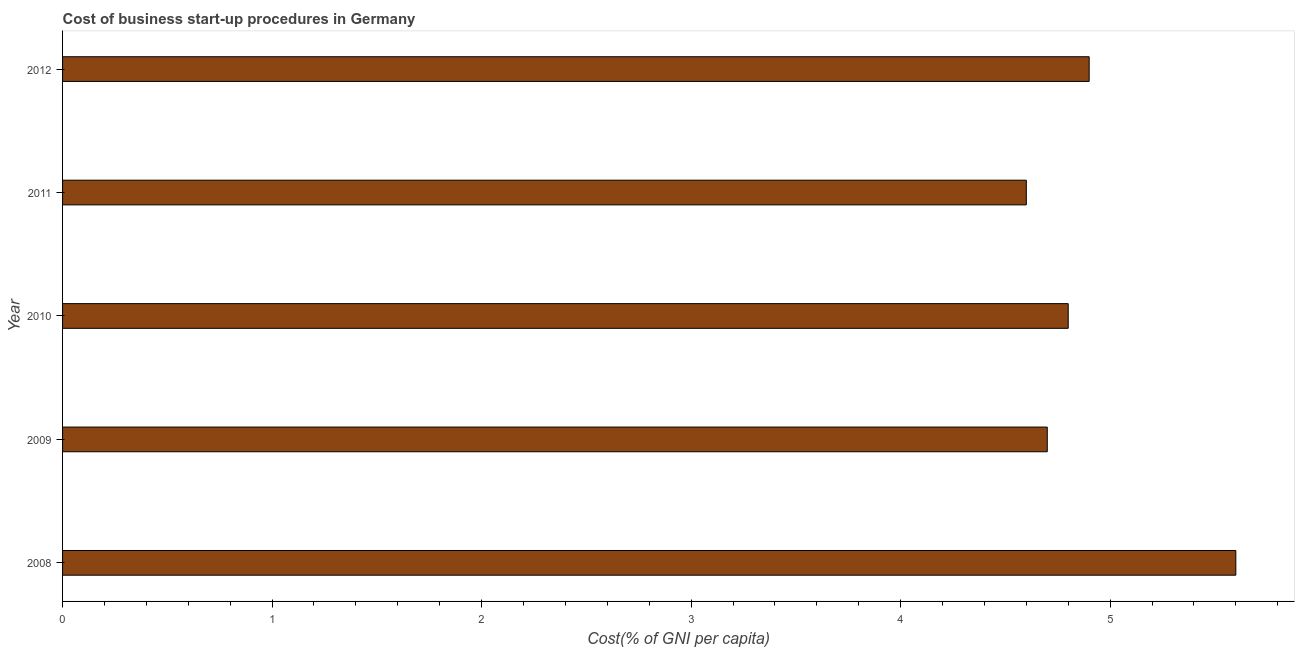Does the graph contain grids?
Provide a succinct answer. No. What is the title of the graph?
Ensure brevity in your answer.  Cost of business start-up procedures in Germany. What is the label or title of the X-axis?
Ensure brevity in your answer.  Cost(% of GNI per capita). Across all years, what is the minimum cost of business startup procedures?
Your answer should be compact. 4.6. In which year was the cost of business startup procedures minimum?
Keep it short and to the point. 2011. What is the sum of the cost of business startup procedures?
Offer a terse response. 24.6. What is the average cost of business startup procedures per year?
Your answer should be compact. 4.92. What is the median cost of business startup procedures?
Make the answer very short. 4.8. In how many years, is the cost of business startup procedures greater than 1.8 %?
Offer a very short reply. 5. Do a majority of the years between 2010 and 2012 (inclusive) have cost of business startup procedures greater than 2.4 %?
Keep it short and to the point. Yes. What is the ratio of the cost of business startup procedures in 2009 to that in 2011?
Ensure brevity in your answer.  1.02. Is the cost of business startup procedures in 2009 less than that in 2012?
Offer a terse response. Yes. What is the difference between the highest and the second highest cost of business startup procedures?
Give a very brief answer. 0.7. How many bars are there?
Provide a succinct answer. 5. Are all the bars in the graph horizontal?
Your answer should be compact. Yes. How many years are there in the graph?
Offer a very short reply. 5. Are the values on the major ticks of X-axis written in scientific E-notation?
Ensure brevity in your answer.  No. What is the Cost(% of GNI per capita) of 2008?
Your response must be concise. 5.6. What is the Cost(% of GNI per capita) in 2009?
Your answer should be very brief. 4.7. What is the Cost(% of GNI per capita) of 2010?
Provide a short and direct response. 4.8. What is the Cost(% of GNI per capita) of 2011?
Your answer should be compact. 4.6. What is the difference between the Cost(% of GNI per capita) in 2008 and 2009?
Provide a succinct answer. 0.9. What is the difference between the Cost(% of GNI per capita) in 2008 and 2010?
Keep it short and to the point. 0.8. What is the difference between the Cost(% of GNI per capita) in 2008 and 2011?
Offer a very short reply. 1. What is the difference between the Cost(% of GNI per capita) in 2009 and 2010?
Offer a terse response. -0.1. What is the difference between the Cost(% of GNI per capita) in 2009 and 2012?
Your response must be concise. -0.2. What is the difference between the Cost(% of GNI per capita) in 2010 and 2011?
Keep it short and to the point. 0.2. What is the difference between the Cost(% of GNI per capita) in 2011 and 2012?
Make the answer very short. -0.3. What is the ratio of the Cost(% of GNI per capita) in 2008 to that in 2009?
Provide a succinct answer. 1.19. What is the ratio of the Cost(% of GNI per capita) in 2008 to that in 2010?
Your response must be concise. 1.17. What is the ratio of the Cost(% of GNI per capita) in 2008 to that in 2011?
Provide a succinct answer. 1.22. What is the ratio of the Cost(% of GNI per capita) in 2008 to that in 2012?
Your response must be concise. 1.14. What is the ratio of the Cost(% of GNI per capita) in 2009 to that in 2010?
Your answer should be compact. 0.98. What is the ratio of the Cost(% of GNI per capita) in 2009 to that in 2011?
Offer a terse response. 1.02. What is the ratio of the Cost(% of GNI per capita) in 2009 to that in 2012?
Give a very brief answer. 0.96. What is the ratio of the Cost(% of GNI per capita) in 2010 to that in 2011?
Your answer should be very brief. 1.04. What is the ratio of the Cost(% of GNI per capita) in 2010 to that in 2012?
Your answer should be compact. 0.98. What is the ratio of the Cost(% of GNI per capita) in 2011 to that in 2012?
Keep it short and to the point. 0.94. 